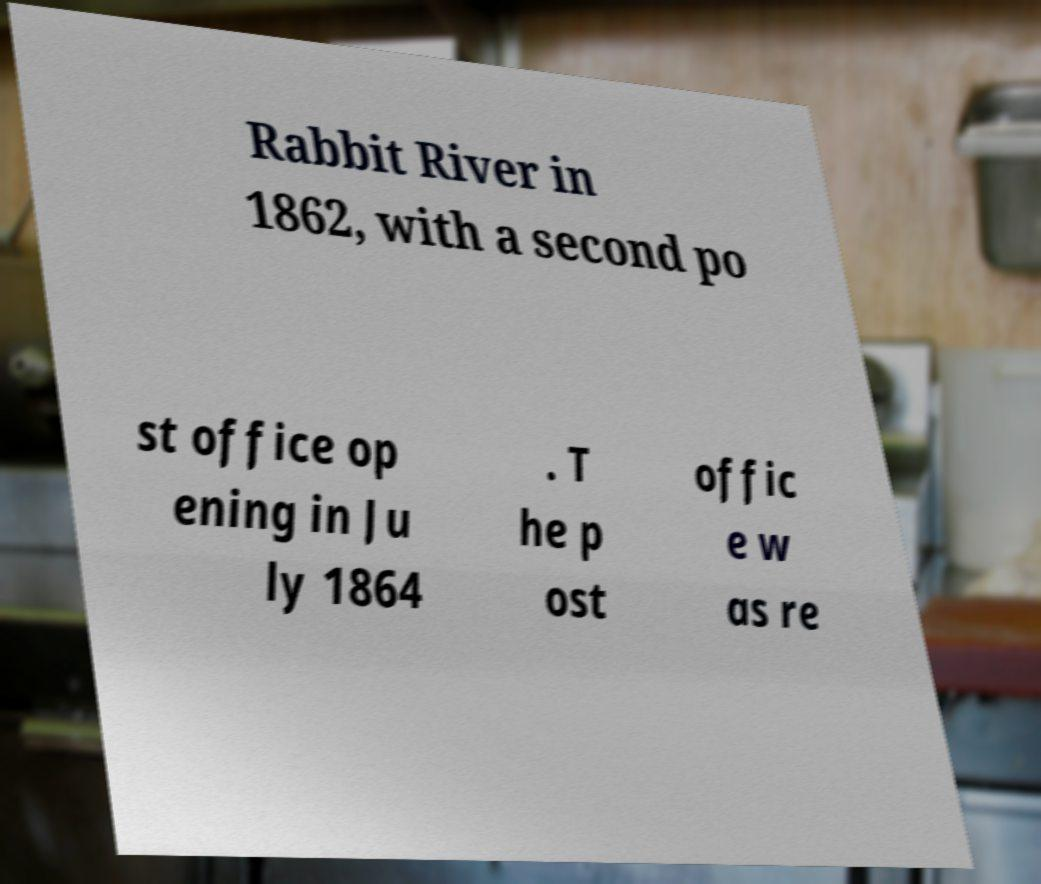For documentation purposes, I need the text within this image transcribed. Could you provide that? Rabbit River in 1862, with a second po st office op ening in Ju ly 1864 . T he p ost offic e w as re 